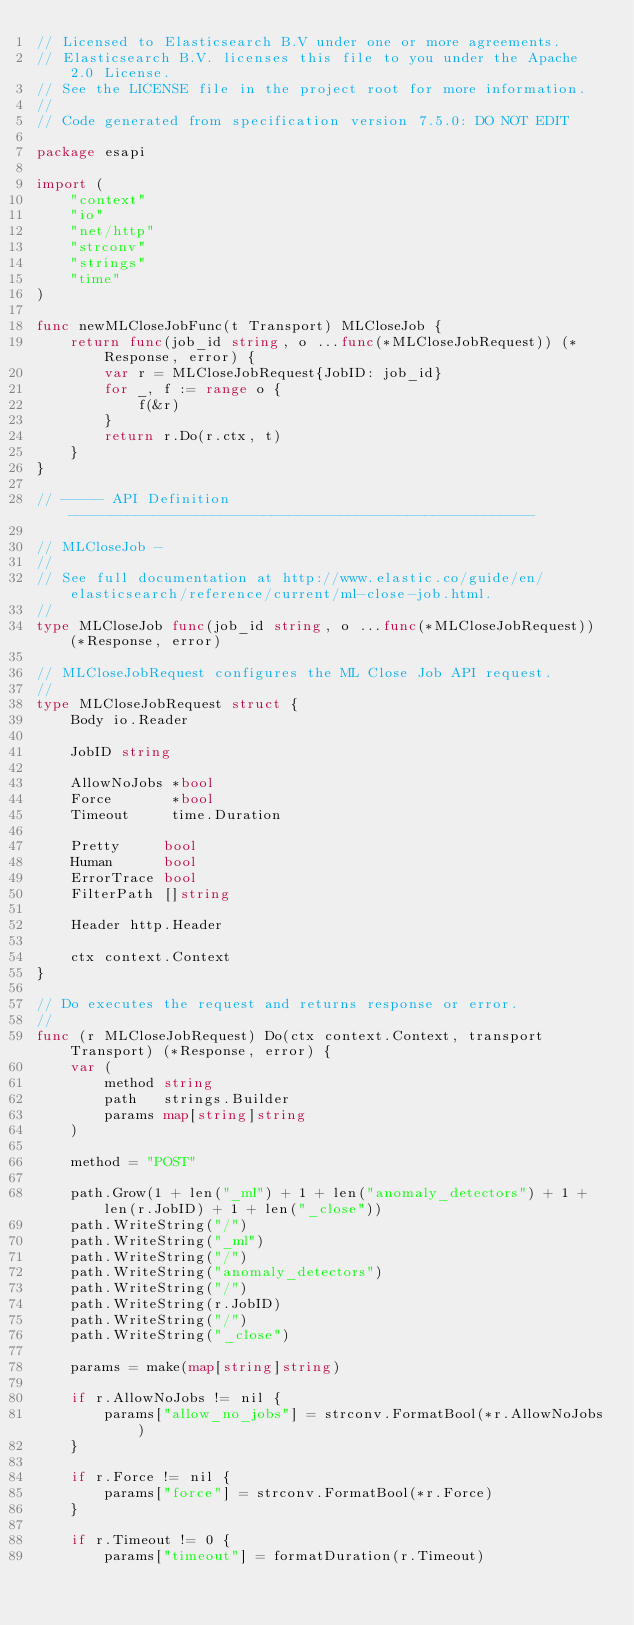Convert code to text. <code><loc_0><loc_0><loc_500><loc_500><_Go_>// Licensed to Elasticsearch B.V under one or more agreements.
// Elasticsearch B.V. licenses this file to you under the Apache 2.0 License.
// See the LICENSE file in the project root for more information.
//
// Code generated from specification version 7.5.0: DO NOT EDIT

package esapi

import (
	"context"
	"io"
	"net/http"
	"strconv"
	"strings"
	"time"
)

func newMLCloseJobFunc(t Transport) MLCloseJob {
	return func(job_id string, o ...func(*MLCloseJobRequest)) (*Response, error) {
		var r = MLCloseJobRequest{JobID: job_id}
		for _, f := range o {
			f(&r)
		}
		return r.Do(r.ctx, t)
	}
}

// ----- API Definition -------------------------------------------------------

// MLCloseJob -
//
// See full documentation at http://www.elastic.co/guide/en/elasticsearch/reference/current/ml-close-job.html.
//
type MLCloseJob func(job_id string, o ...func(*MLCloseJobRequest)) (*Response, error)

// MLCloseJobRequest configures the ML Close Job API request.
//
type MLCloseJobRequest struct {
	Body io.Reader

	JobID string

	AllowNoJobs *bool
	Force       *bool
	Timeout     time.Duration

	Pretty     bool
	Human      bool
	ErrorTrace bool
	FilterPath []string

	Header http.Header

	ctx context.Context
}

// Do executes the request and returns response or error.
//
func (r MLCloseJobRequest) Do(ctx context.Context, transport Transport) (*Response, error) {
	var (
		method string
		path   strings.Builder
		params map[string]string
	)

	method = "POST"

	path.Grow(1 + len("_ml") + 1 + len("anomaly_detectors") + 1 + len(r.JobID) + 1 + len("_close"))
	path.WriteString("/")
	path.WriteString("_ml")
	path.WriteString("/")
	path.WriteString("anomaly_detectors")
	path.WriteString("/")
	path.WriteString(r.JobID)
	path.WriteString("/")
	path.WriteString("_close")

	params = make(map[string]string)

	if r.AllowNoJobs != nil {
		params["allow_no_jobs"] = strconv.FormatBool(*r.AllowNoJobs)
	}

	if r.Force != nil {
		params["force"] = strconv.FormatBool(*r.Force)
	}

	if r.Timeout != 0 {
		params["timeout"] = formatDuration(r.Timeout)</code> 